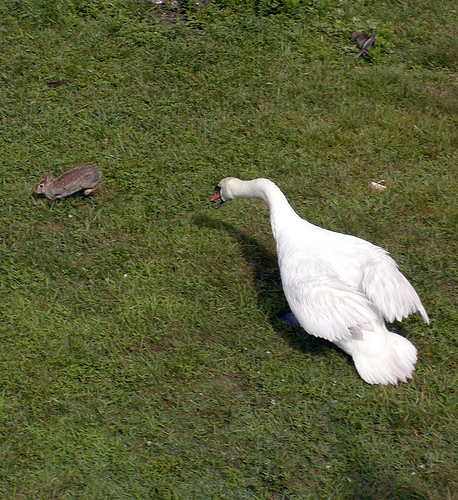<image>
Is there a grass on the bird? No. The grass is not positioned on the bird. They may be near each other, but the grass is not supported by or resting on top of the bird. Is the rabbit above the geese? No. The rabbit is not positioned above the geese. The vertical arrangement shows a different relationship. 